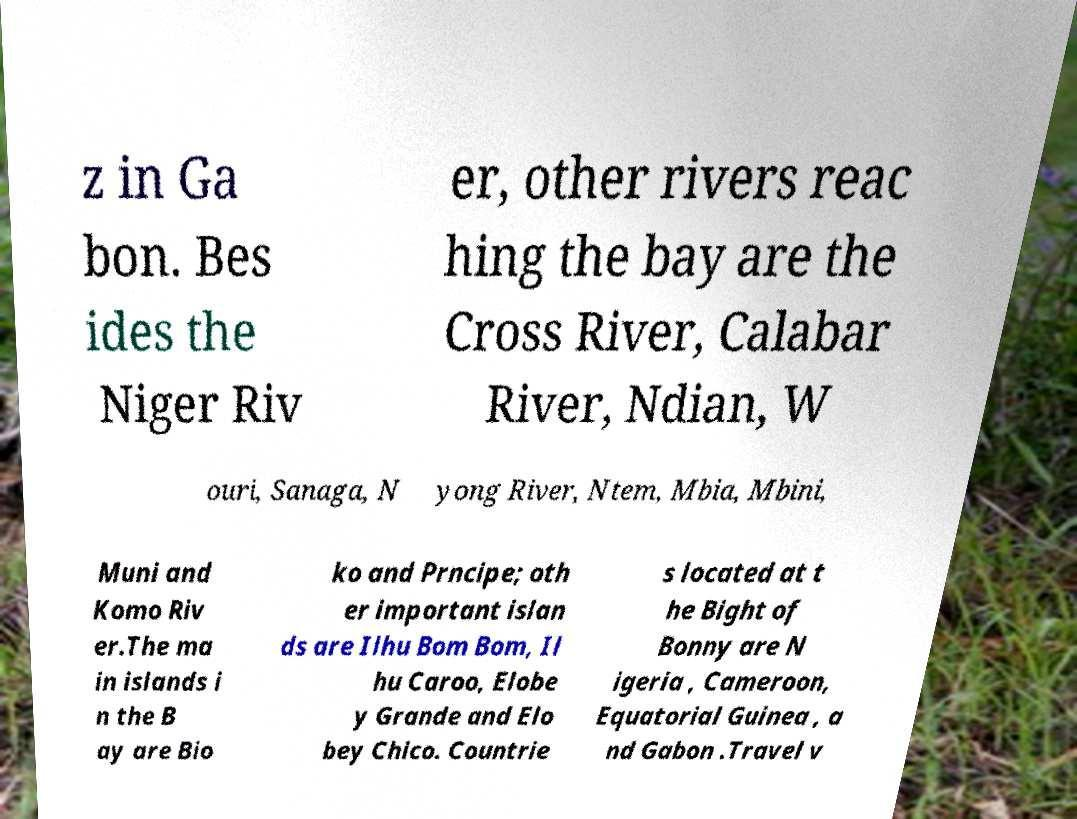Please read and relay the text visible in this image. What does it say? z in Ga bon. Bes ides the Niger Riv er, other rivers reac hing the bay are the Cross River, Calabar River, Ndian, W ouri, Sanaga, N yong River, Ntem, Mbia, Mbini, Muni and Komo Riv er.The ma in islands i n the B ay are Bio ko and Prncipe; oth er important islan ds are Ilhu Bom Bom, Il hu Caroo, Elobe y Grande and Elo bey Chico. Countrie s located at t he Bight of Bonny are N igeria , Cameroon, Equatorial Guinea , a nd Gabon .Travel v 